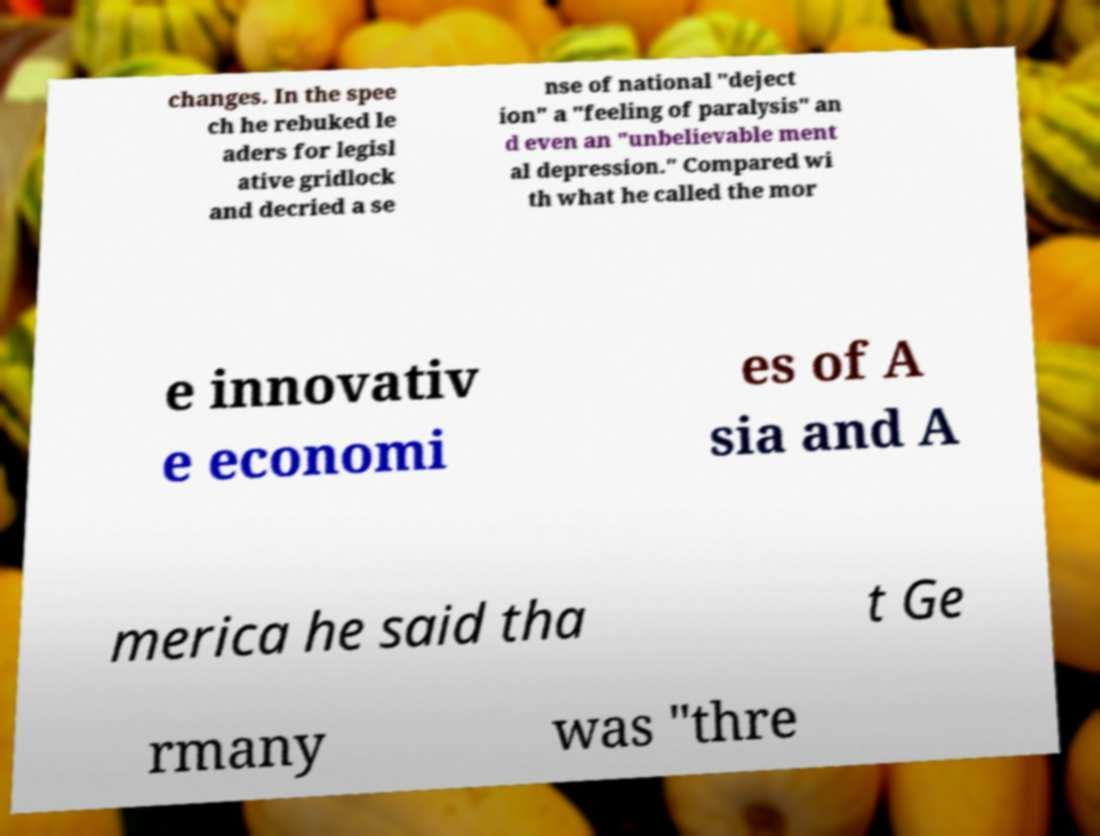Please read and relay the text visible in this image. What does it say? changes. In the spee ch he rebuked le aders for legisl ative gridlock and decried a se nse of national "deject ion" a "feeling of paralysis" an d even an "unbelievable ment al depression." Compared wi th what he called the mor e innovativ e economi es of A sia and A merica he said tha t Ge rmany was "thre 